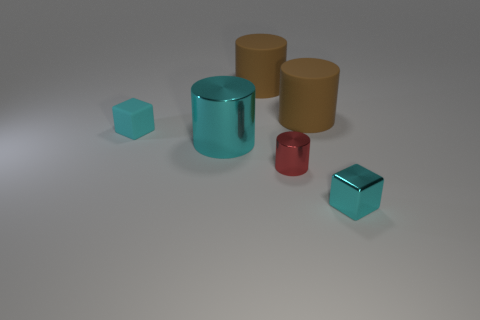Are there other indicators in the image that might help identify the materials further? Yes, besides the reflections, we could also look for shadows and the way objects cast them, any visible indentations or deformations that might suggest a material's hardness or malleability, and any inconsistencies in color or texture that may reveal more about each object's material composition.  Between the cyan and red objects, which one seems to have a harder surface? The cyan object, likely made of metal, appears to have a harder surface due to its reflective nature and the absence of visible deformations. The red object, with a less shiny and more opaque appearance, might be either plastic or rubber, which typically have softer surfaces that do not reflect light as clearly. 